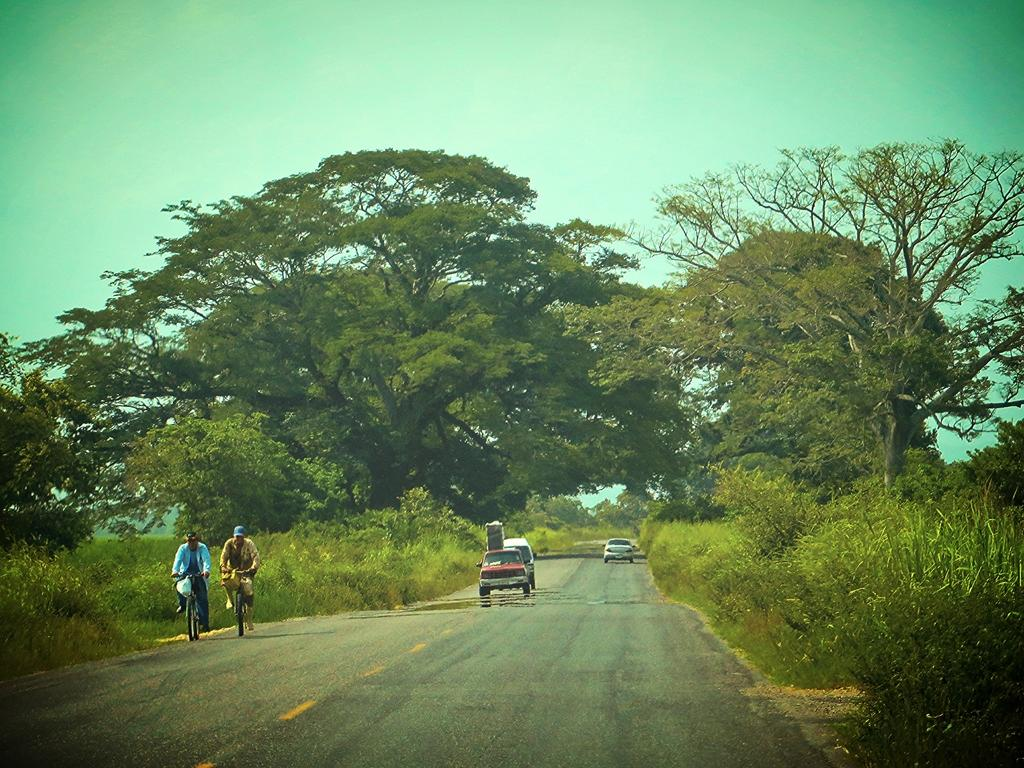What type of vehicles can be seen in the image? There are cars in the image. What are the people doing in the image? The people are riding bicycles in the image. What type of vegetation is visible in the image? There are trees visible in the image. What color is the sky in the image? The sky is blue in the image. Can you see a gun in the image? No, there is no gun present in the image. What type of health services are available in the image? There is no mention of health services in the image; it primarily features cars, bicycles, trees, and the sky. 